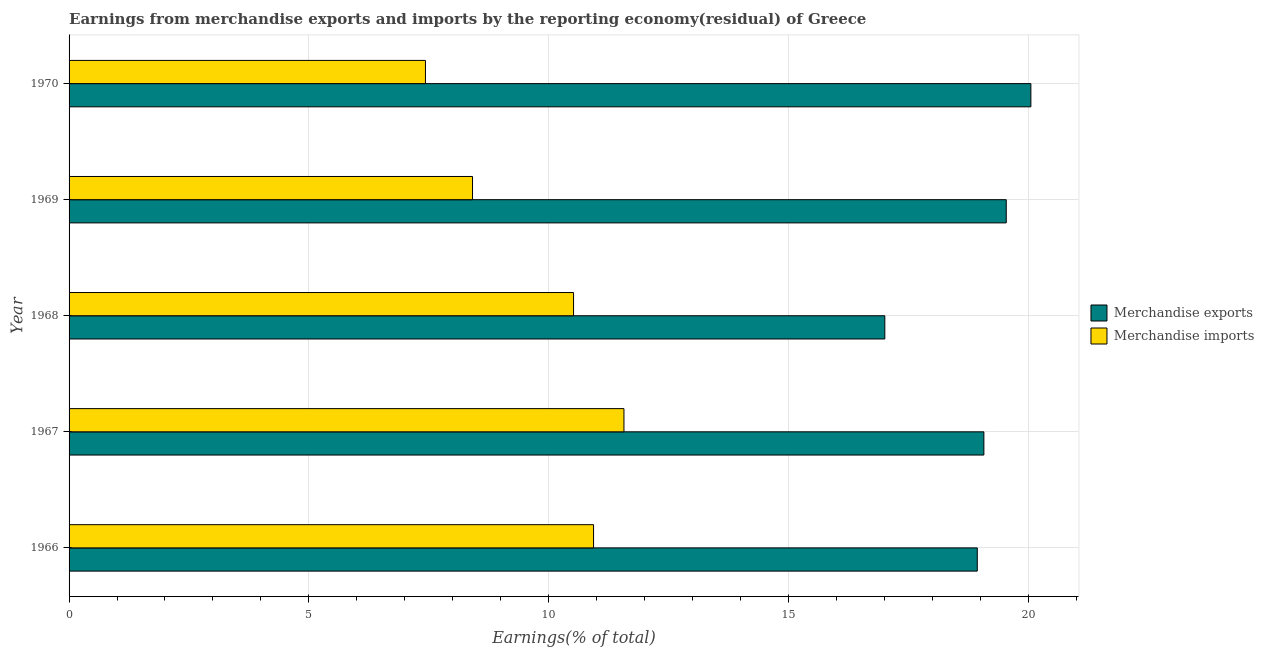How many bars are there on the 5th tick from the bottom?
Your answer should be very brief. 2. What is the label of the 5th group of bars from the top?
Give a very brief answer. 1966. In how many cases, is the number of bars for a given year not equal to the number of legend labels?
Offer a very short reply. 0. What is the earnings from merchandise imports in 1970?
Your response must be concise. 7.43. Across all years, what is the maximum earnings from merchandise imports?
Ensure brevity in your answer.  11.57. Across all years, what is the minimum earnings from merchandise exports?
Make the answer very short. 17.01. In which year was the earnings from merchandise imports maximum?
Offer a very short reply. 1967. In which year was the earnings from merchandise exports minimum?
Your answer should be very brief. 1968. What is the total earnings from merchandise exports in the graph?
Provide a succinct answer. 94.63. What is the difference between the earnings from merchandise exports in 1967 and that in 1968?
Your response must be concise. 2.07. What is the difference between the earnings from merchandise imports in 1967 and the earnings from merchandise exports in 1969?
Your response must be concise. -7.97. What is the average earnings from merchandise imports per year?
Give a very brief answer. 9.78. In the year 1966, what is the difference between the earnings from merchandise exports and earnings from merchandise imports?
Your answer should be very brief. 8. In how many years, is the earnings from merchandise exports greater than 7 %?
Offer a very short reply. 5. What is the ratio of the earnings from merchandise imports in 1967 to that in 1970?
Make the answer very short. 1.56. Is the difference between the earnings from merchandise imports in 1966 and 1969 greater than the difference between the earnings from merchandise exports in 1966 and 1969?
Give a very brief answer. Yes. What is the difference between the highest and the second highest earnings from merchandise imports?
Your answer should be very brief. 0.63. What is the difference between the highest and the lowest earnings from merchandise imports?
Provide a short and direct response. 4.14. Is the sum of the earnings from merchandise exports in 1967 and 1968 greater than the maximum earnings from merchandise imports across all years?
Provide a succinct answer. Yes. What does the 2nd bar from the top in 1967 represents?
Offer a very short reply. Merchandise exports. What does the 1st bar from the bottom in 1968 represents?
Offer a very short reply. Merchandise exports. How many years are there in the graph?
Provide a short and direct response. 5. What is the difference between two consecutive major ticks on the X-axis?
Offer a very short reply. 5. Are the values on the major ticks of X-axis written in scientific E-notation?
Offer a very short reply. No. Does the graph contain any zero values?
Your answer should be compact. No. How many legend labels are there?
Offer a very short reply. 2. What is the title of the graph?
Your answer should be compact. Earnings from merchandise exports and imports by the reporting economy(residual) of Greece. What is the label or title of the X-axis?
Give a very brief answer. Earnings(% of total). What is the label or title of the Y-axis?
Provide a succinct answer. Year. What is the Earnings(% of total) of Merchandise exports in 1966?
Keep it short and to the point. 18.94. What is the Earnings(% of total) of Merchandise imports in 1966?
Give a very brief answer. 10.94. What is the Earnings(% of total) in Merchandise exports in 1967?
Offer a very short reply. 19.08. What is the Earnings(% of total) of Merchandise imports in 1967?
Provide a short and direct response. 11.57. What is the Earnings(% of total) in Merchandise exports in 1968?
Your answer should be very brief. 17.01. What is the Earnings(% of total) in Merchandise imports in 1968?
Your answer should be compact. 10.52. What is the Earnings(% of total) in Merchandise exports in 1969?
Your answer should be compact. 19.55. What is the Earnings(% of total) in Merchandise imports in 1969?
Keep it short and to the point. 8.41. What is the Earnings(% of total) of Merchandise exports in 1970?
Your response must be concise. 20.06. What is the Earnings(% of total) of Merchandise imports in 1970?
Offer a terse response. 7.43. Across all years, what is the maximum Earnings(% of total) of Merchandise exports?
Offer a terse response. 20.06. Across all years, what is the maximum Earnings(% of total) of Merchandise imports?
Give a very brief answer. 11.57. Across all years, what is the minimum Earnings(% of total) of Merchandise exports?
Your answer should be compact. 17.01. Across all years, what is the minimum Earnings(% of total) of Merchandise imports?
Keep it short and to the point. 7.43. What is the total Earnings(% of total) in Merchandise exports in the graph?
Your response must be concise. 94.63. What is the total Earnings(% of total) in Merchandise imports in the graph?
Ensure brevity in your answer.  48.88. What is the difference between the Earnings(% of total) of Merchandise exports in 1966 and that in 1967?
Your answer should be very brief. -0.14. What is the difference between the Earnings(% of total) of Merchandise imports in 1966 and that in 1967?
Provide a succinct answer. -0.63. What is the difference between the Earnings(% of total) in Merchandise exports in 1966 and that in 1968?
Your answer should be very brief. 1.93. What is the difference between the Earnings(% of total) of Merchandise imports in 1966 and that in 1968?
Provide a short and direct response. 0.42. What is the difference between the Earnings(% of total) of Merchandise exports in 1966 and that in 1969?
Provide a short and direct response. -0.6. What is the difference between the Earnings(% of total) of Merchandise imports in 1966 and that in 1969?
Your response must be concise. 2.52. What is the difference between the Earnings(% of total) of Merchandise exports in 1966 and that in 1970?
Provide a short and direct response. -1.12. What is the difference between the Earnings(% of total) in Merchandise imports in 1966 and that in 1970?
Give a very brief answer. 3.51. What is the difference between the Earnings(% of total) of Merchandise exports in 1967 and that in 1968?
Your response must be concise. 2.07. What is the difference between the Earnings(% of total) in Merchandise imports in 1967 and that in 1968?
Offer a terse response. 1.05. What is the difference between the Earnings(% of total) in Merchandise exports in 1967 and that in 1969?
Make the answer very short. -0.47. What is the difference between the Earnings(% of total) of Merchandise imports in 1967 and that in 1969?
Offer a very short reply. 3.16. What is the difference between the Earnings(% of total) of Merchandise exports in 1967 and that in 1970?
Give a very brief answer. -0.98. What is the difference between the Earnings(% of total) of Merchandise imports in 1967 and that in 1970?
Provide a short and direct response. 4.14. What is the difference between the Earnings(% of total) of Merchandise exports in 1968 and that in 1969?
Provide a short and direct response. -2.53. What is the difference between the Earnings(% of total) in Merchandise imports in 1968 and that in 1969?
Give a very brief answer. 2.11. What is the difference between the Earnings(% of total) of Merchandise exports in 1968 and that in 1970?
Offer a terse response. -3.05. What is the difference between the Earnings(% of total) of Merchandise imports in 1968 and that in 1970?
Your response must be concise. 3.09. What is the difference between the Earnings(% of total) in Merchandise exports in 1969 and that in 1970?
Provide a succinct answer. -0.51. What is the difference between the Earnings(% of total) of Merchandise imports in 1969 and that in 1970?
Ensure brevity in your answer.  0.98. What is the difference between the Earnings(% of total) of Merchandise exports in 1966 and the Earnings(% of total) of Merchandise imports in 1967?
Keep it short and to the point. 7.37. What is the difference between the Earnings(% of total) in Merchandise exports in 1966 and the Earnings(% of total) in Merchandise imports in 1968?
Provide a short and direct response. 8.42. What is the difference between the Earnings(% of total) of Merchandise exports in 1966 and the Earnings(% of total) of Merchandise imports in 1969?
Offer a terse response. 10.53. What is the difference between the Earnings(% of total) in Merchandise exports in 1966 and the Earnings(% of total) in Merchandise imports in 1970?
Give a very brief answer. 11.51. What is the difference between the Earnings(% of total) in Merchandise exports in 1967 and the Earnings(% of total) in Merchandise imports in 1968?
Ensure brevity in your answer.  8.56. What is the difference between the Earnings(% of total) of Merchandise exports in 1967 and the Earnings(% of total) of Merchandise imports in 1969?
Provide a short and direct response. 10.66. What is the difference between the Earnings(% of total) of Merchandise exports in 1967 and the Earnings(% of total) of Merchandise imports in 1970?
Keep it short and to the point. 11.65. What is the difference between the Earnings(% of total) in Merchandise exports in 1968 and the Earnings(% of total) in Merchandise imports in 1969?
Ensure brevity in your answer.  8.6. What is the difference between the Earnings(% of total) of Merchandise exports in 1968 and the Earnings(% of total) of Merchandise imports in 1970?
Your answer should be compact. 9.58. What is the difference between the Earnings(% of total) in Merchandise exports in 1969 and the Earnings(% of total) in Merchandise imports in 1970?
Make the answer very short. 12.11. What is the average Earnings(% of total) in Merchandise exports per year?
Make the answer very short. 18.93. What is the average Earnings(% of total) in Merchandise imports per year?
Make the answer very short. 9.78. In the year 1966, what is the difference between the Earnings(% of total) of Merchandise exports and Earnings(% of total) of Merchandise imports?
Keep it short and to the point. 8. In the year 1967, what is the difference between the Earnings(% of total) of Merchandise exports and Earnings(% of total) of Merchandise imports?
Provide a short and direct response. 7.51. In the year 1968, what is the difference between the Earnings(% of total) of Merchandise exports and Earnings(% of total) of Merchandise imports?
Your answer should be very brief. 6.49. In the year 1969, what is the difference between the Earnings(% of total) of Merchandise exports and Earnings(% of total) of Merchandise imports?
Make the answer very short. 11.13. In the year 1970, what is the difference between the Earnings(% of total) of Merchandise exports and Earnings(% of total) of Merchandise imports?
Ensure brevity in your answer.  12.63. What is the ratio of the Earnings(% of total) in Merchandise imports in 1966 to that in 1967?
Offer a very short reply. 0.95. What is the ratio of the Earnings(% of total) of Merchandise exports in 1966 to that in 1968?
Make the answer very short. 1.11. What is the ratio of the Earnings(% of total) in Merchandise imports in 1966 to that in 1968?
Provide a short and direct response. 1.04. What is the ratio of the Earnings(% of total) of Merchandise exports in 1966 to that in 1969?
Offer a terse response. 0.97. What is the ratio of the Earnings(% of total) of Merchandise exports in 1966 to that in 1970?
Give a very brief answer. 0.94. What is the ratio of the Earnings(% of total) in Merchandise imports in 1966 to that in 1970?
Make the answer very short. 1.47. What is the ratio of the Earnings(% of total) in Merchandise exports in 1967 to that in 1968?
Provide a succinct answer. 1.12. What is the ratio of the Earnings(% of total) in Merchandise imports in 1967 to that in 1968?
Provide a short and direct response. 1.1. What is the ratio of the Earnings(% of total) in Merchandise exports in 1967 to that in 1969?
Your response must be concise. 0.98. What is the ratio of the Earnings(% of total) of Merchandise imports in 1967 to that in 1969?
Your answer should be very brief. 1.38. What is the ratio of the Earnings(% of total) in Merchandise exports in 1967 to that in 1970?
Your answer should be compact. 0.95. What is the ratio of the Earnings(% of total) of Merchandise imports in 1967 to that in 1970?
Offer a terse response. 1.56. What is the ratio of the Earnings(% of total) of Merchandise exports in 1968 to that in 1969?
Your response must be concise. 0.87. What is the ratio of the Earnings(% of total) of Merchandise imports in 1968 to that in 1969?
Give a very brief answer. 1.25. What is the ratio of the Earnings(% of total) in Merchandise exports in 1968 to that in 1970?
Your answer should be compact. 0.85. What is the ratio of the Earnings(% of total) in Merchandise imports in 1968 to that in 1970?
Make the answer very short. 1.42. What is the ratio of the Earnings(% of total) of Merchandise exports in 1969 to that in 1970?
Give a very brief answer. 0.97. What is the ratio of the Earnings(% of total) of Merchandise imports in 1969 to that in 1970?
Provide a short and direct response. 1.13. What is the difference between the highest and the second highest Earnings(% of total) of Merchandise exports?
Your answer should be compact. 0.51. What is the difference between the highest and the second highest Earnings(% of total) of Merchandise imports?
Keep it short and to the point. 0.63. What is the difference between the highest and the lowest Earnings(% of total) in Merchandise exports?
Your answer should be compact. 3.05. What is the difference between the highest and the lowest Earnings(% of total) in Merchandise imports?
Your answer should be very brief. 4.14. 